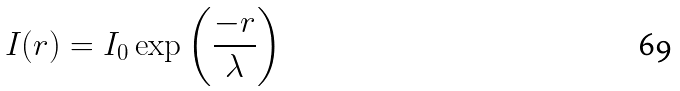<formula> <loc_0><loc_0><loc_500><loc_500>I ( r ) = I _ { 0 } \exp { \left ( \frac { - r } { \lambda } \right ) }</formula> 